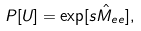<formula> <loc_0><loc_0><loc_500><loc_500>P [ U ] = \exp [ s \hat { M } _ { e e } ] ,</formula> 